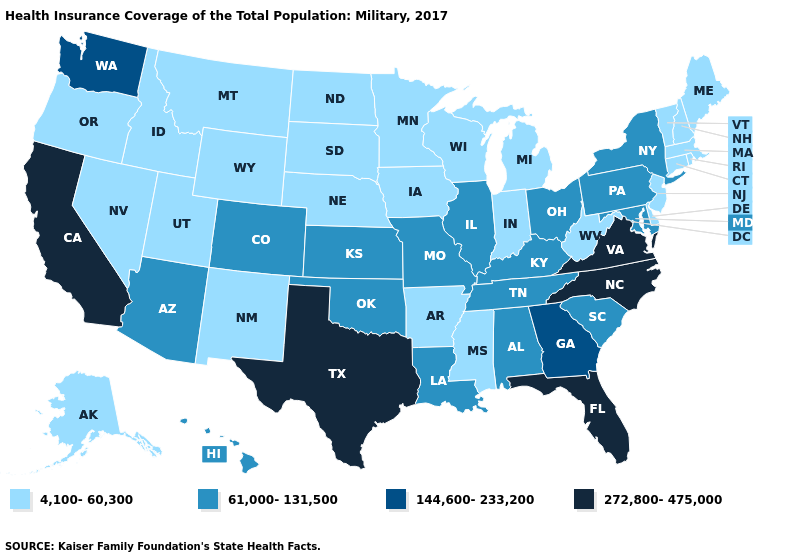Which states have the lowest value in the USA?
Quick response, please. Alaska, Arkansas, Connecticut, Delaware, Idaho, Indiana, Iowa, Maine, Massachusetts, Michigan, Minnesota, Mississippi, Montana, Nebraska, Nevada, New Hampshire, New Jersey, New Mexico, North Dakota, Oregon, Rhode Island, South Dakota, Utah, Vermont, West Virginia, Wisconsin, Wyoming. Name the states that have a value in the range 4,100-60,300?
Be succinct. Alaska, Arkansas, Connecticut, Delaware, Idaho, Indiana, Iowa, Maine, Massachusetts, Michigan, Minnesota, Mississippi, Montana, Nebraska, Nevada, New Hampshire, New Jersey, New Mexico, North Dakota, Oregon, Rhode Island, South Dakota, Utah, Vermont, West Virginia, Wisconsin, Wyoming. What is the value of Maine?
Answer briefly. 4,100-60,300. What is the highest value in states that border Arkansas?
Short answer required. 272,800-475,000. What is the value of Missouri?
Answer briefly. 61,000-131,500. What is the value of North Carolina?
Be succinct. 272,800-475,000. Name the states that have a value in the range 4,100-60,300?
Short answer required. Alaska, Arkansas, Connecticut, Delaware, Idaho, Indiana, Iowa, Maine, Massachusetts, Michigan, Minnesota, Mississippi, Montana, Nebraska, Nevada, New Hampshire, New Jersey, New Mexico, North Dakota, Oregon, Rhode Island, South Dakota, Utah, Vermont, West Virginia, Wisconsin, Wyoming. Which states hav the highest value in the South?
Write a very short answer. Florida, North Carolina, Texas, Virginia. Does Maryland have a higher value than Mississippi?
Answer briefly. Yes. Does Nebraska have the same value as Georgia?
Concise answer only. No. What is the highest value in states that border Wyoming?
Write a very short answer. 61,000-131,500. Does California have the highest value in the West?
Concise answer only. Yes. Does Michigan have the same value as Hawaii?
Keep it brief. No. Name the states that have a value in the range 144,600-233,200?
Quick response, please. Georgia, Washington. What is the lowest value in the West?
Quick response, please. 4,100-60,300. 